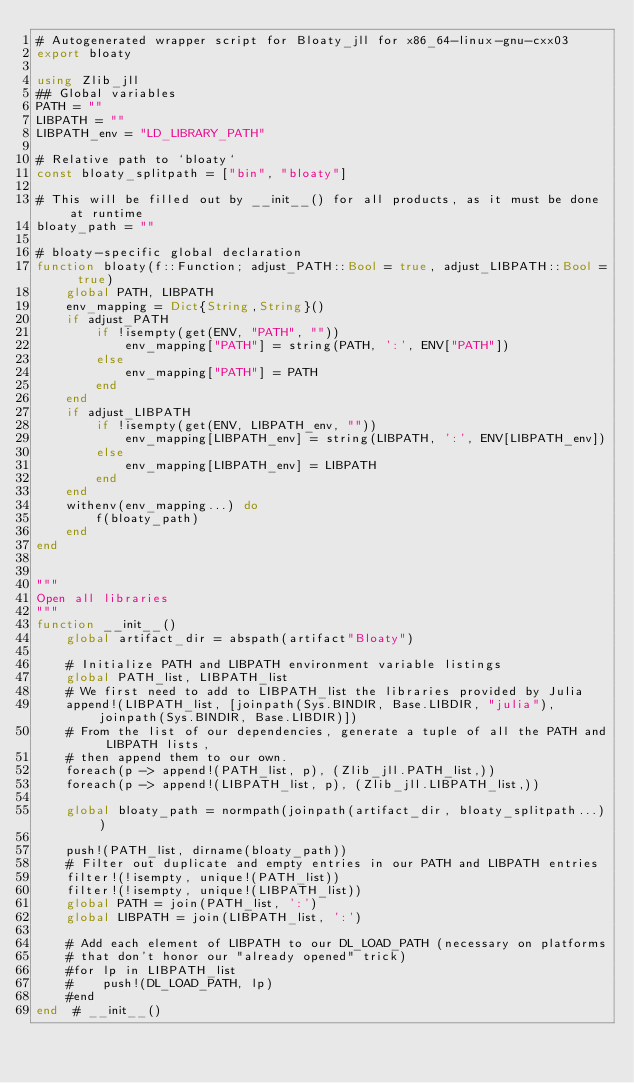Convert code to text. <code><loc_0><loc_0><loc_500><loc_500><_Julia_># Autogenerated wrapper script for Bloaty_jll for x86_64-linux-gnu-cxx03
export bloaty

using Zlib_jll
## Global variables
PATH = ""
LIBPATH = ""
LIBPATH_env = "LD_LIBRARY_PATH"

# Relative path to `bloaty`
const bloaty_splitpath = ["bin", "bloaty"]

# This will be filled out by __init__() for all products, as it must be done at runtime
bloaty_path = ""

# bloaty-specific global declaration
function bloaty(f::Function; adjust_PATH::Bool = true, adjust_LIBPATH::Bool = true)
    global PATH, LIBPATH
    env_mapping = Dict{String,String}()
    if adjust_PATH
        if !isempty(get(ENV, "PATH", ""))
            env_mapping["PATH"] = string(PATH, ':', ENV["PATH"])
        else
            env_mapping["PATH"] = PATH
        end
    end
    if adjust_LIBPATH
        if !isempty(get(ENV, LIBPATH_env, ""))
            env_mapping[LIBPATH_env] = string(LIBPATH, ':', ENV[LIBPATH_env])
        else
            env_mapping[LIBPATH_env] = LIBPATH
        end
    end
    withenv(env_mapping...) do
        f(bloaty_path)
    end
end


"""
Open all libraries
"""
function __init__()
    global artifact_dir = abspath(artifact"Bloaty")

    # Initialize PATH and LIBPATH environment variable listings
    global PATH_list, LIBPATH_list
    # We first need to add to LIBPATH_list the libraries provided by Julia
    append!(LIBPATH_list, [joinpath(Sys.BINDIR, Base.LIBDIR, "julia"), joinpath(Sys.BINDIR, Base.LIBDIR)])
    # From the list of our dependencies, generate a tuple of all the PATH and LIBPATH lists,
    # then append them to our own.
    foreach(p -> append!(PATH_list, p), (Zlib_jll.PATH_list,))
    foreach(p -> append!(LIBPATH_list, p), (Zlib_jll.LIBPATH_list,))

    global bloaty_path = normpath(joinpath(artifact_dir, bloaty_splitpath...))

    push!(PATH_list, dirname(bloaty_path))
    # Filter out duplicate and empty entries in our PATH and LIBPATH entries
    filter!(!isempty, unique!(PATH_list))
    filter!(!isempty, unique!(LIBPATH_list))
    global PATH = join(PATH_list, ':')
    global LIBPATH = join(LIBPATH_list, ':')

    # Add each element of LIBPATH to our DL_LOAD_PATH (necessary on platforms
    # that don't honor our "already opened" trick)
    #for lp in LIBPATH_list
    #    push!(DL_LOAD_PATH, lp)
    #end
end  # __init__()

</code> 